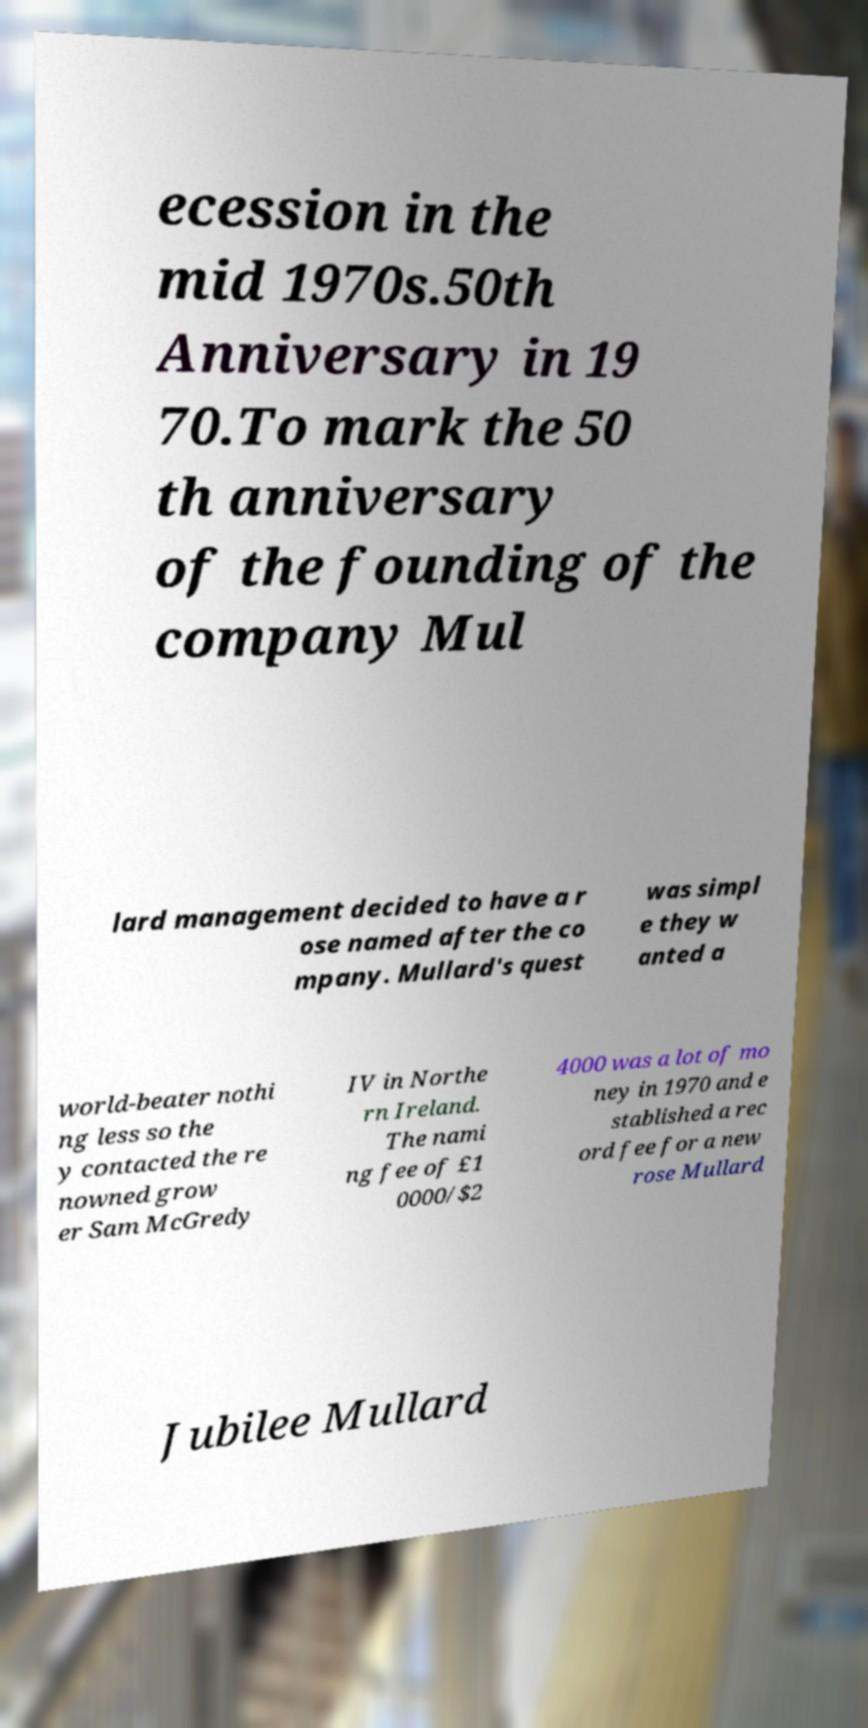Could you extract and type out the text from this image? ecession in the mid 1970s.50th Anniversary in 19 70.To mark the 50 th anniversary of the founding of the company Mul lard management decided to have a r ose named after the co mpany. Mullard's quest was simpl e they w anted a world-beater nothi ng less so the y contacted the re nowned grow er Sam McGredy IV in Northe rn Ireland. The nami ng fee of £1 0000/$2 4000 was a lot of mo ney in 1970 and e stablished a rec ord fee for a new rose Mullard Jubilee Mullard 